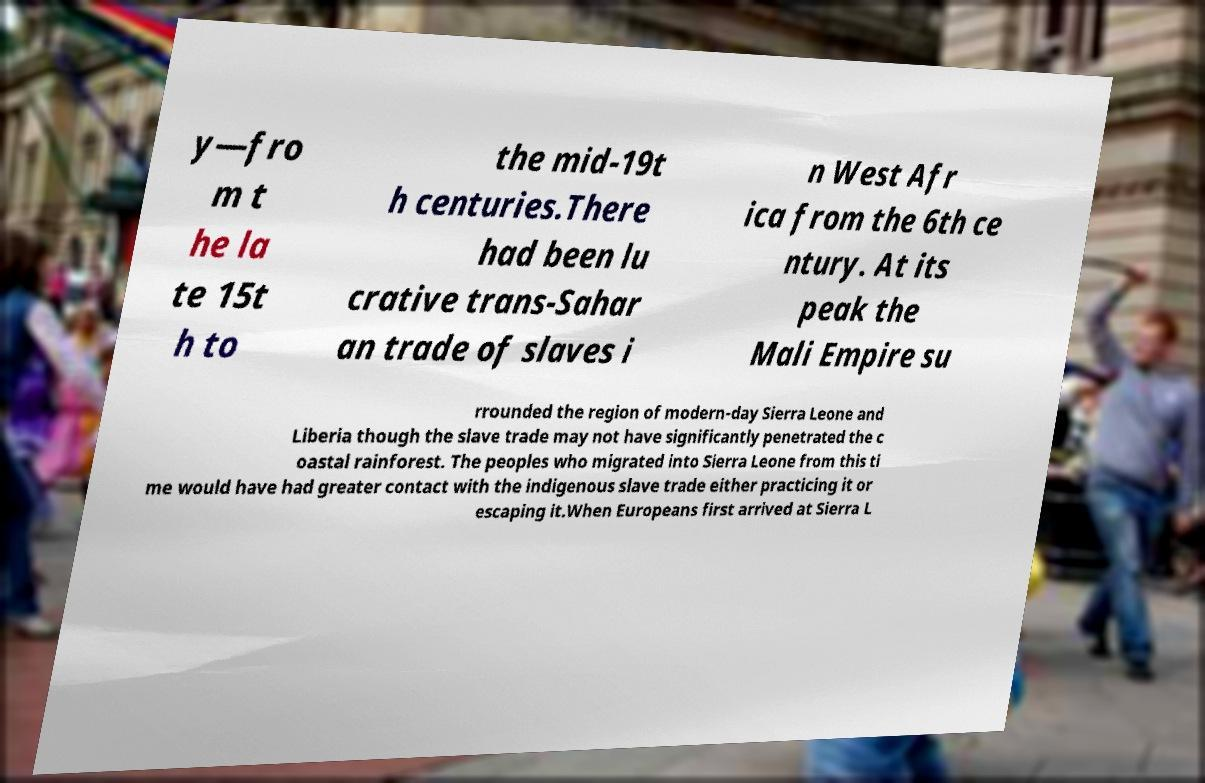Could you extract and type out the text from this image? y—fro m t he la te 15t h to the mid-19t h centuries.There had been lu crative trans-Sahar an trade of slaves i n West Afr ica from the 6th ce ntury. At its peak the Mali Empire su rrounded the region of modern-day Sierra Leone and Liberia though the slave trade may not have significantly penetrated the c oastal rainforest. The peoples who migrated into Sierra Leone from this ti me would have had greater contact with the indigenous slave trade either practicing it or escaping it.When Europeans first arrived at Sierra L 